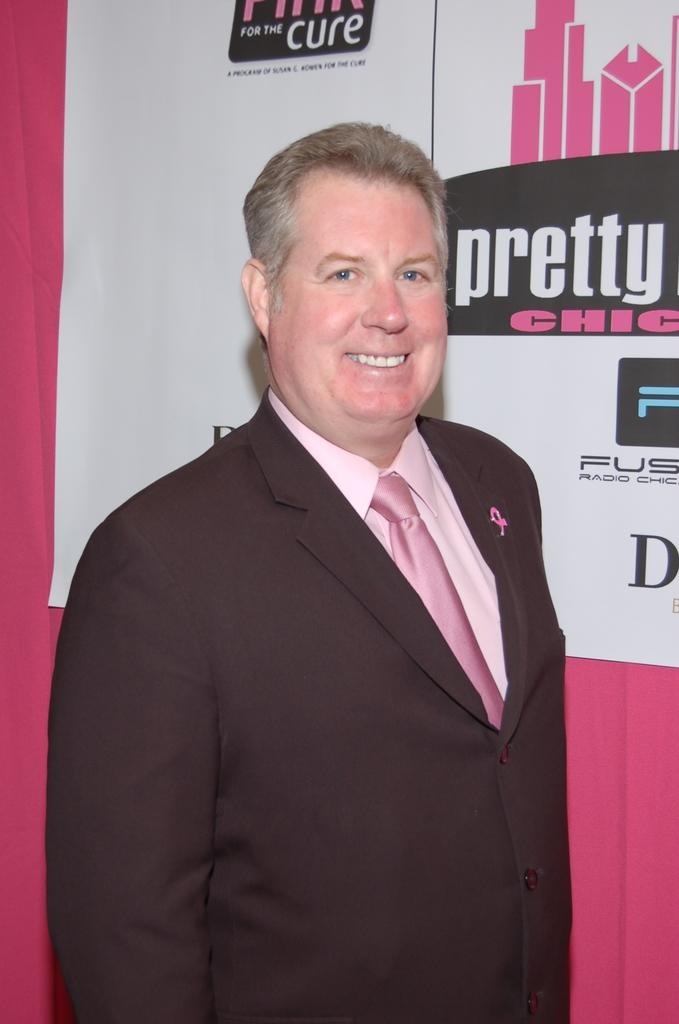<image>
Summarize the visual content of the image. a man stands in front of a Pretty Chic sign 